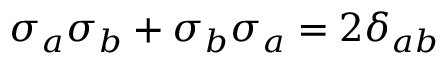<formula> <loc_0><loc_0><loc_500><loc_500>\sigma _ { a } \sigma _ { b } + \sigma _ { b } \sigma _ { a } = 2 \delta _ { a b }</formula> 